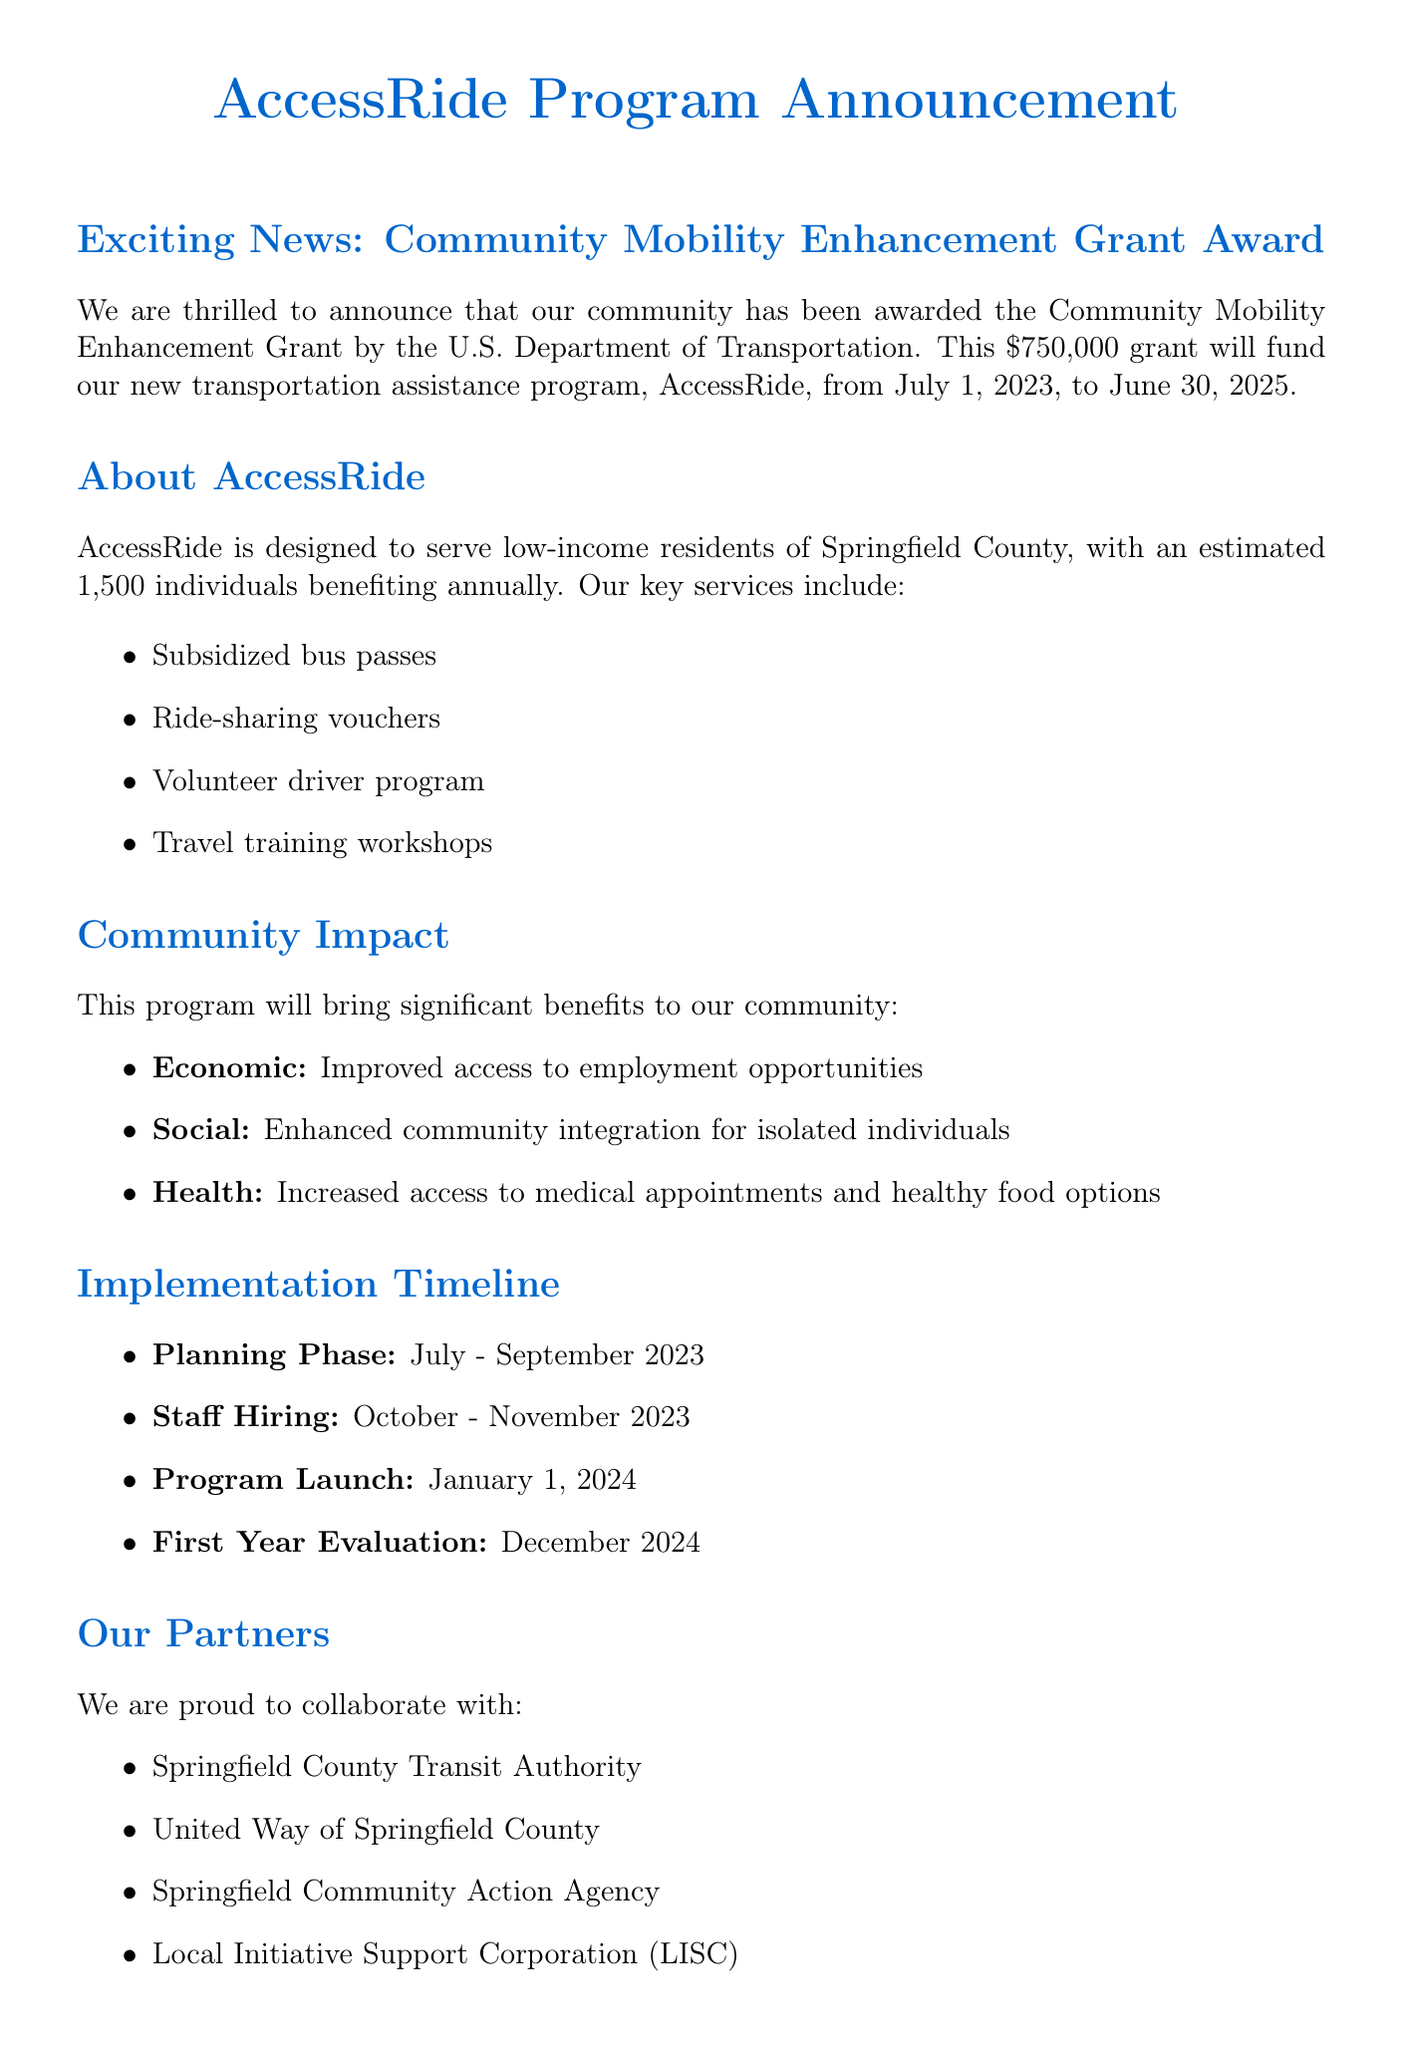What is the name of the grant? The name of the grant is mentioned in the document as the "Community Mobility Enhancement Grant."
Answer: Community Mobility Enhancement Grant Who awarded the grant? The entity that awarded the grant is specified in the document as the "U.S. Department of Transportation."
Answer: U.S. Department of Transportation What is the amount of the grant? The document states the grant amount as "$750,000."
Answer: $750,000 What is the duration of the grant period? The grant period is detailed in the document, indicating it runs from "July 1, 2023" to "June 30, 2025."
Answer: July 1, 2023 - June 30, 2025 How many individuals are estimated to benefit annually from AccessRide? The estimated number of beneficiaries is specified as "1,500 individuals annually."
Answer: 1,500 individuals annually What key service involves travel training? The specific key service that relates to travel training is referred to as "Travel training workshops."
Answer: Travel training workshops What are the economic benefits mentioned? The economic benefits articulated in the document are "Improved access to employment opportunities."
Answer: Improved access to employment opportunities When will the program launch? The launch date of the program is given as "January 1, 2024."
Answer: January 1, 2024 Who is the program coordinator? The name of the program coordinator is provided as "Maria Rodriguez."
Answer: Maria Rodriguez 